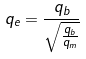<formula> <loc_0><loc_0><loc_500><loc_500>q _ { e } = \frac { q _ { b } } { \sqrt { \frac { q _ { b } } { q _ { m } } } }</formula> 